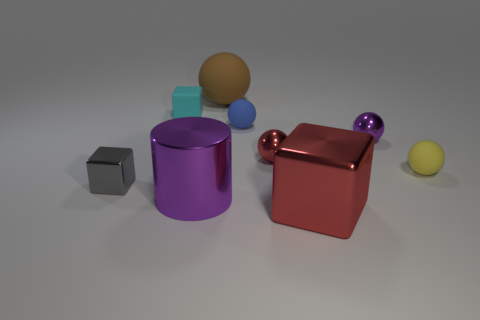There is a big brown matte sphere; are there any tiny purple spheres on the left side of it?
Keep it short and to the point. No. Is the red thing to the left of the red block made of the same material as the sphere behind the matte cube?
Your answer should be very brief. No. How many purple metallic cubes have the same size as the yellow rubber thing?
Ensure brevity in your answer.  0. What is the shape of the metal object that is the same color as the large cylinder?
Ensure brevity in your answer.  Sphere. What is the material of the red object that is behind the gray shiny block?
Provide a short and direct response. Metal. How many tiny metallic things have the same shape as the yellow rubber object?
Provide a short and direct response. 2. What shape is the large brown thing that is made of the same material as the blue ball?
Offer a terse response. Sphere. What shape is the purple metallic object in front of the red thing behind the red metal thing in front of the small yellow object?
Provide a succinct answer. Cylinder. Are there more small yellow objects than purple metal things?
Offer a terse response. No. There is a cyan thing that is the same shape as the gray object; what material is it?
Your answer should be compact. Rubber. 